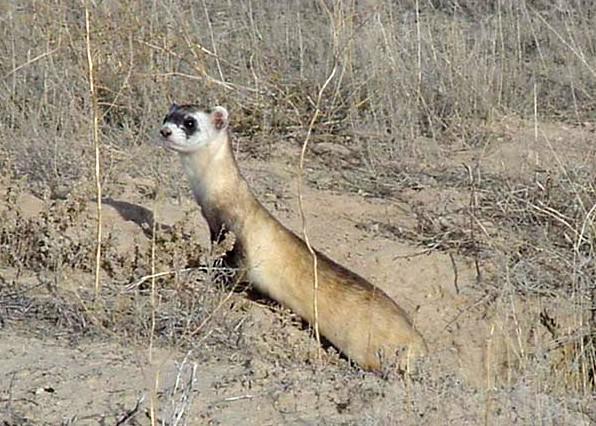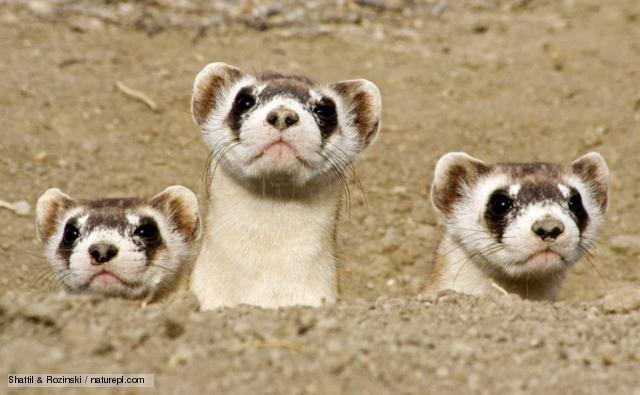The first image is the image on the left, the second image is the image on the right. Examine the images to the left and right. Is the description "Each image shows a single ferret, with its head held upright." accurate? Answer yes or no. No. The first image is the image on the left, the second image is the image on the right. Evaluate the accuracy of this statement regarding the images: "A single animal is poking its head out from the ground.". Is it true? Answer yes or no. No. 